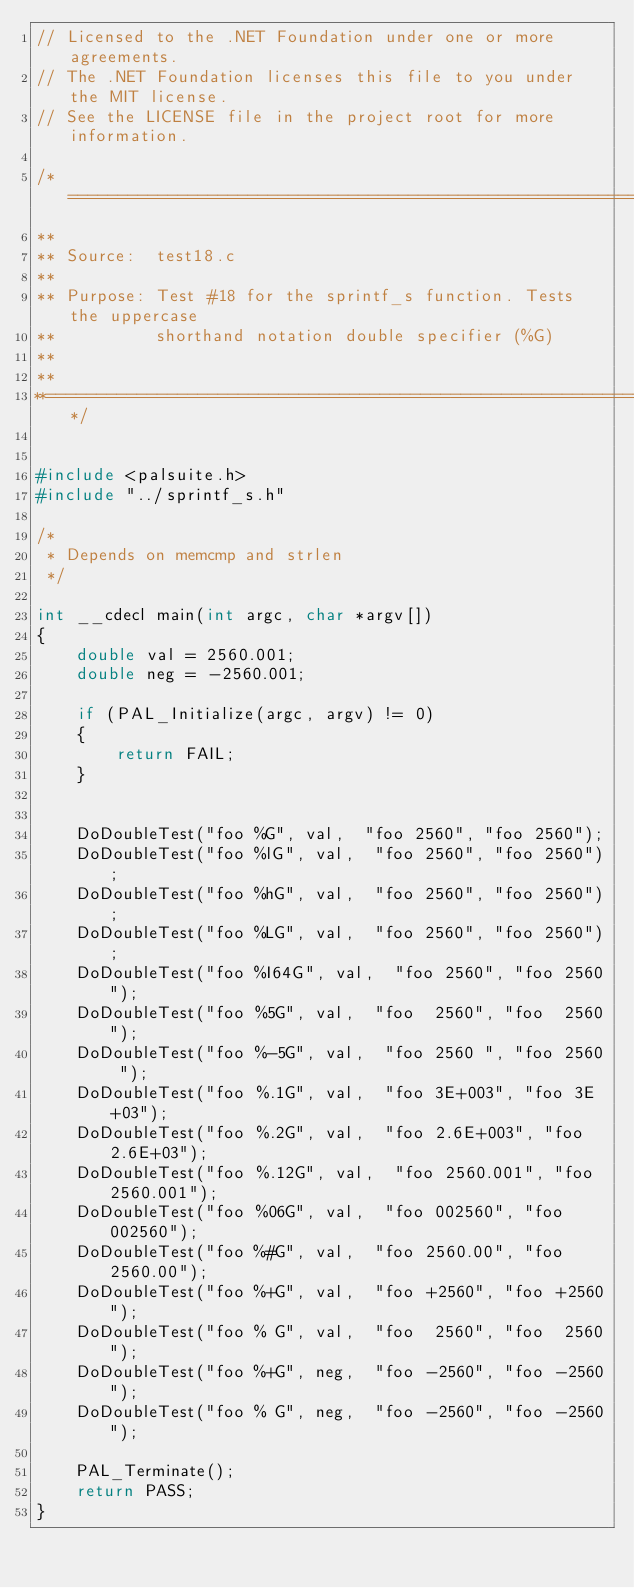Convert code to text. <code><loc_0><loc_0><loc_500><loc_500><_C++_>// Licensed to the .NET Foundation under one or more agreements.
// The .NET Foundation licenses this file to you under the MIT license.
// See the LICENSE file in the project root for more information.

/*============================================================================
**
** Source:  test18.c
**
** Purpose: Test #18 for the sprintf_s function. Tests the uppercase
**          shorthand notation double specifier (%G)
**
**
**==========================================================================*/


#include <palsuite.h>
#include "../sprintf_s.h"

/* 
 * Depends on memcmp and strlen
 */

int __cdecl main(int argc, char *argv[])
{
    double val = 2560.001;
    double neg = -2560.001;
    
    if (PAL_Initialize(argc, argv) != 0)
    {
        return FAIL;
    }


    DoDoubleTest("foo %G", val,  "foo 2560", "foo 2560");
    DoDoubleTest("foo %lG", val,  "foo 2560", "foo 2560");
    DoDoubleTest("foo %hG", val,  "foo 2560", "foo 2560");
    DoDoubleTest("foo %LG", val,  "foo 2560", "foo 2560");
    DoDoubleTest("foo %I64G", val,  "foo 2560", "foo 2560");
    DoDoubleTest("foo %5G", val,  "foo  2560", "foo  2560");
    DoDoubleTest("foo %-5G", val,  "foo 2560 ", "foo 2560 ");
    DoDoubleTest("foo %.1G", val,  "foo 3E+003", "foo 3E+03");
    DoDoubleTest("foo %.2G", val,  "foo 2.6E+003", "foo 2.6E+03");
    DoDoubleTest("foo %.12G", val,  "foo 2560.001", "foo 2560.001");
    DoDoubleTest("foo %06G", val,  "foo 002560", "foo 002560");
    DoDoubleTest("foo %#G", val,  "foo 2560.00", "foo 2560.00");
    DoDoubleTest("foo %+G", val,  "foo +2560", "foo +2560");
    DoDoubleTest("foo % G", val,  "foo  2560", "foo  2560");
    DoDoubleTest("foo %+G", neg,  "foo -2560", "foo -2560");
    DoDoubleTest("foo % G", neg,  "foo -2560", "foo -2560");

    PAL_Terminate();
    return PASS;
}
</code> 